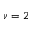<formula> <loc_0><loc_0><loc_500><loc_500>\nu = 2</formula> 